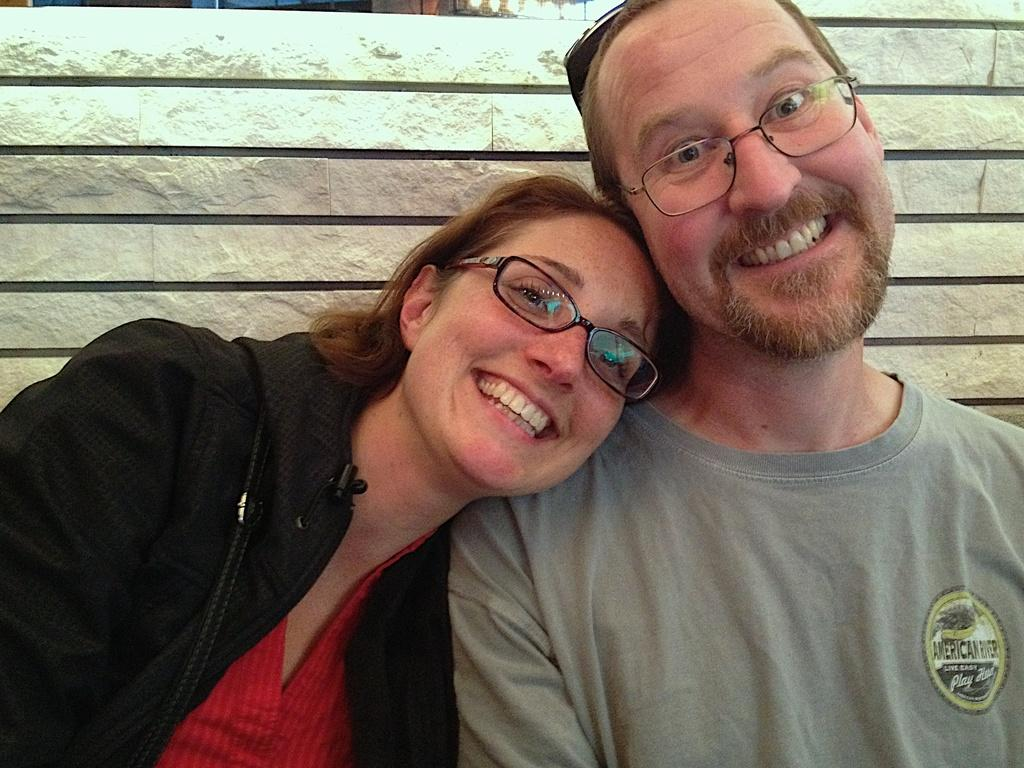Who is present in the image? There is a woman in the image. What is the woman doing in the image? The woman has her head on the shoulder of another person. What can be seen in the background of the image? There is a fence wall in the background of the image. What type of fruit is the woman holding in the image? There is no fruit present in the image, and the woman is not holding anything. 